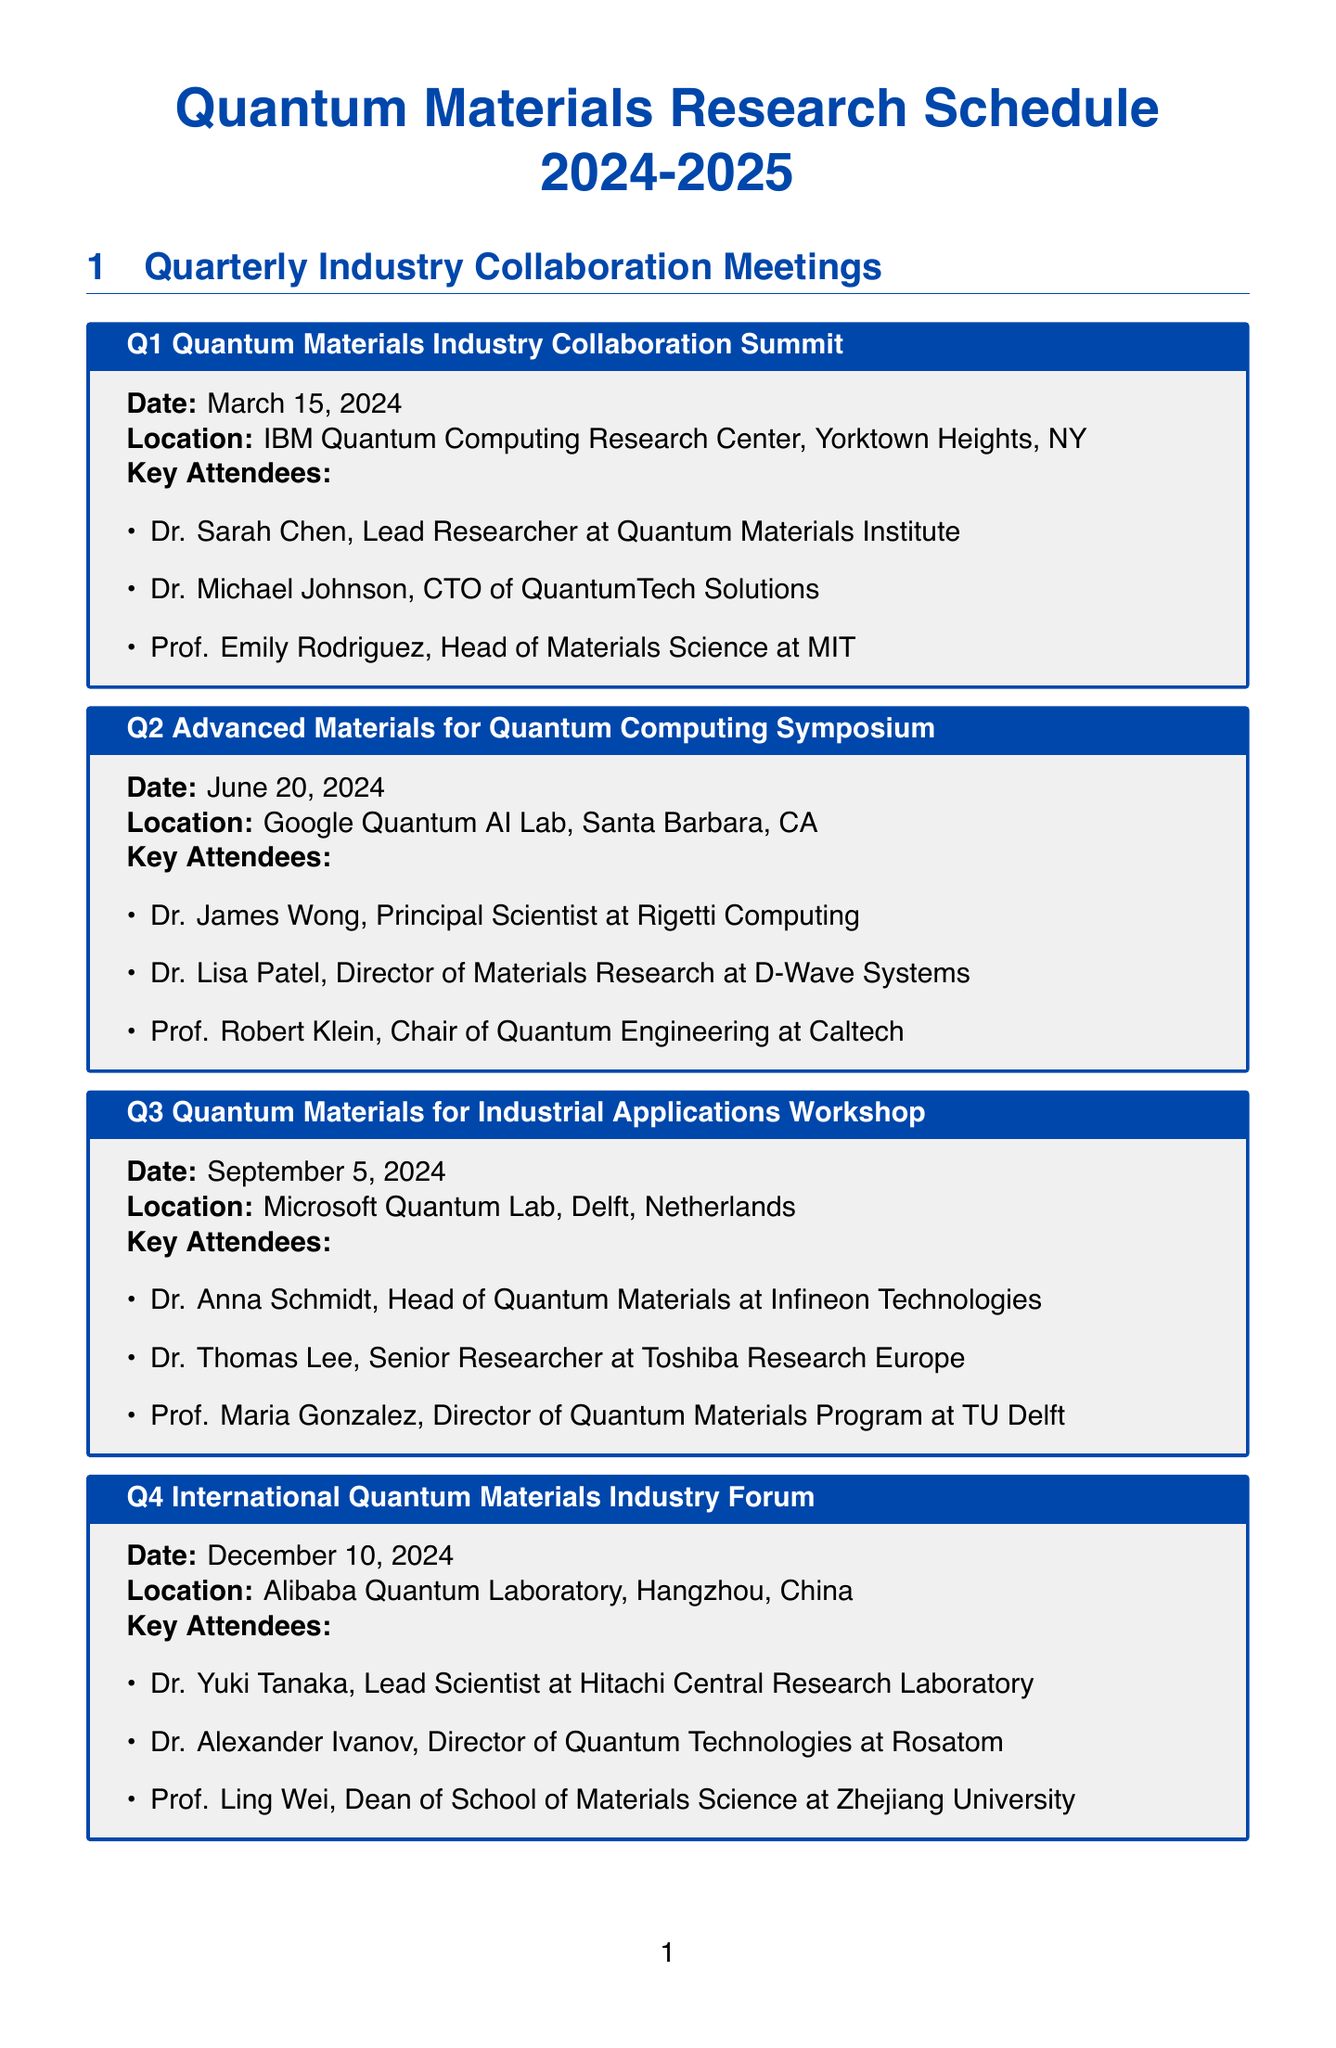What is the date of the Q1 meeting? The date of the Q1 meeting is mentioned in the document as March 15, 2024.
Answer: March 15, 2024 Who is the key attendee at the Q2 symposium? The document lists key attendees for the Q2 symposium, including Dr. James Wong.
Answer: Dr. James Wong What is the deadline for the Quantum Sensing Materials project? The deadline for this project is specified in the document as October 31, 2024.
Answer: October 31, 2024 How many quarterly meetings are scheduled in the document? The document lists four quarterly meetings in total.
Answer: Four Which university is collaborating on the Topological Quantum Computing Materials project? The collaborator mentioned for this project is Delft University of Technology.
Answer: Delft University of Technology What is the title of the Q4 meeting? The title of the Q4 meeting is presented in the document as International Quantum Materials Industry Forum.
Answer: International Quantum Materials Industry Forum What is one of the deliverables for the Superconducting Qubit project? The document provides deliverables for this project, one of which is a report on improved coherence times in aluminum-based qubits.
Answer: Report on improved coherence times in aluminum-based qubits When is the Q3 workshop scheduled? The Q3 workshop is scheduled on September 5, 2024, according to the document.
Answer: September 5, 2024 What is the focus of the Q1 meeting? The document indicates that the focus of the Q1 meeting is on Quantum Materials Industry Collaboration.
Answer: Quantum Materials Industry Collaboration 